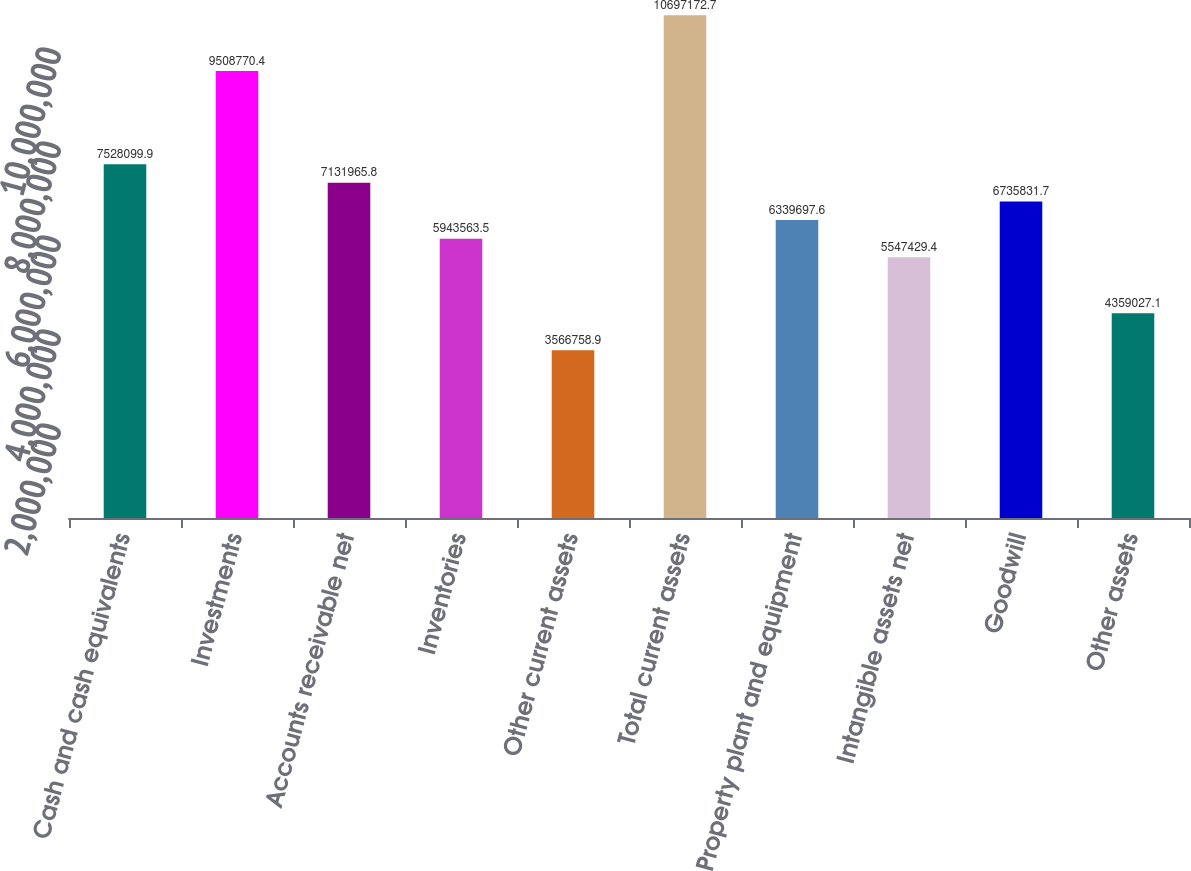<chart> <loc_0><loc_0><loc_500><loc_500><bar_chart><fcel>Cash and cash equivalents<fcel>Investments<fcel>Accounts receivable net<fcel>Inventories<fcel>Other current assets<fcel>Total current assets<fcel>Property plant and equipment<fcel>Intangible assets net<fcel>Goodwill<fcel>Other assets<nl><fcel>7.5281e+06<fcel>9.50877e+06<fcel>7.13197e+06<fcel>5.94356e+06<fcel>3.56676e+06<fcel>1.06972e+07<fcel>6.3397e+06<fcel>5.54743e+06<fcel>6.73583e+06<fcel>4.35903e+06<nl></chart> 